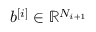<formula> <loc_0><loc_0><loc_500><loc_500>b ^ { [ i ] } \in \mathbb { R } ^ { N _ { i + 1 } }</formula> 